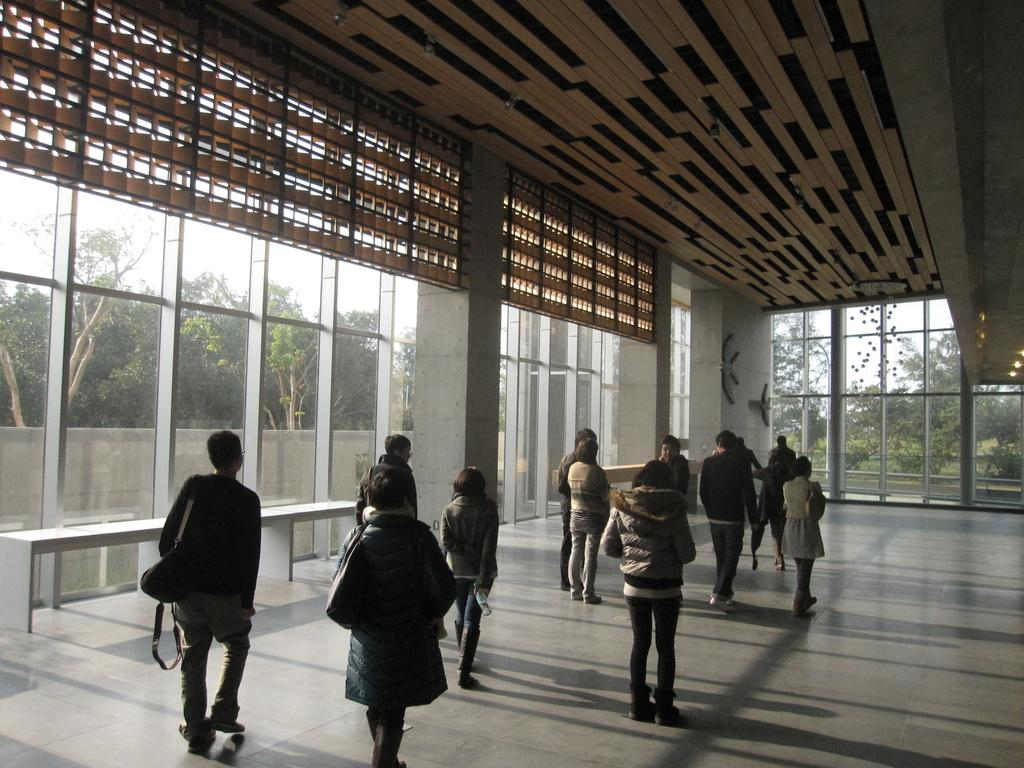How many people are in the image? There is a group of people standing in the image. Where are the people standing? The people are standing on the floor. What can be seen behind the people? There are glass windows behind the people, and a wall is visible behind the windows. What is visible beyond the wall? Trees are present behind the wall, and the sky is visible in the background. How many pies are being held by the people in the image? There is no mention of pies in the image; the people are not holding any pies. 